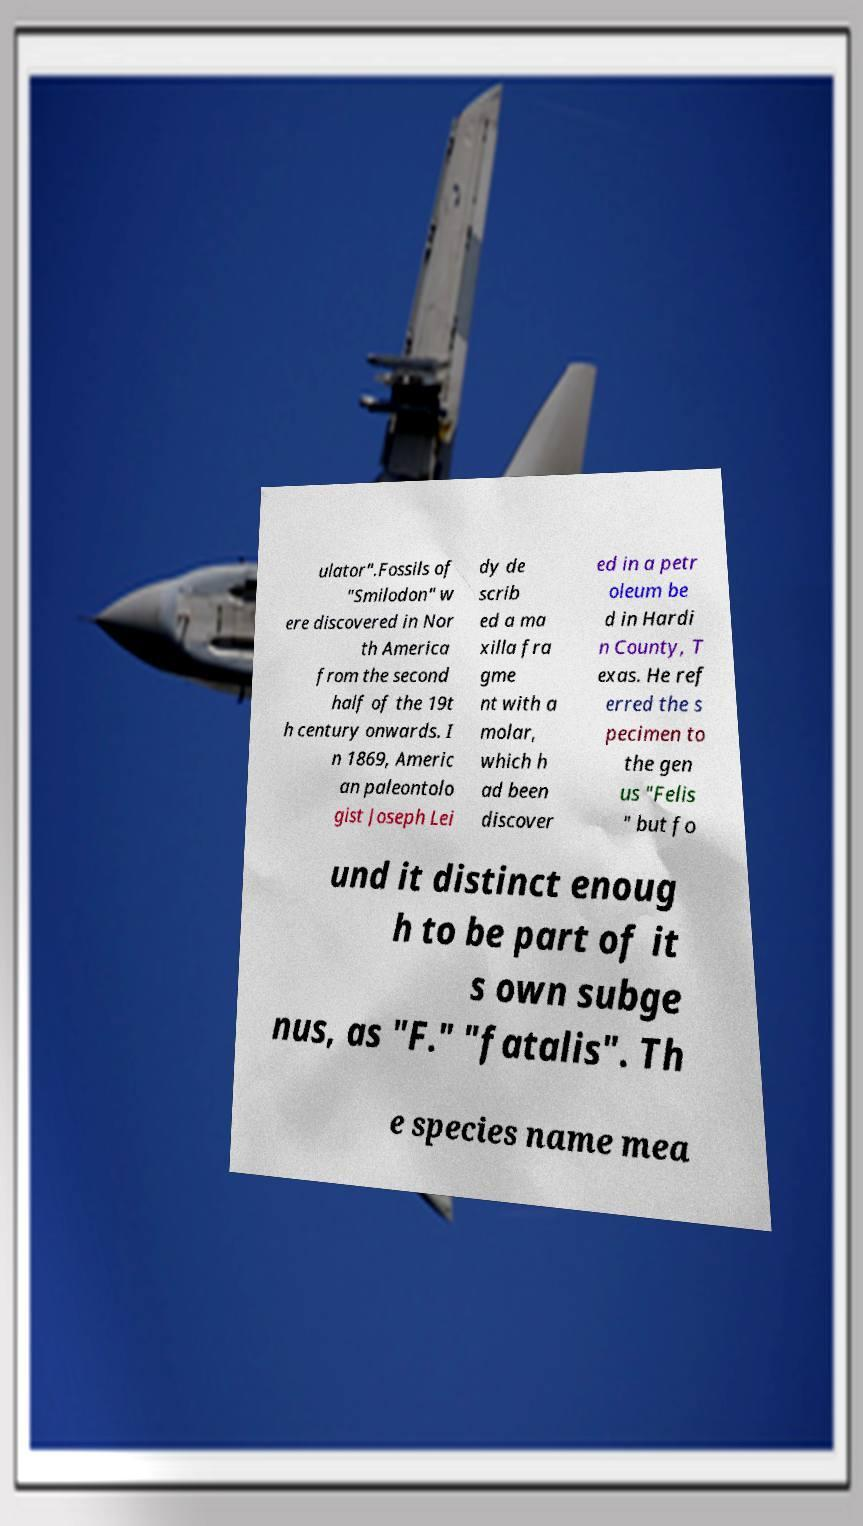There's text embedded in this image that I need extracted. Can you transcribe it verbatim? ulator".Fossils of "Smilodon" w ere discovered in Nor th America from the second half of the 19t h century onwards. I n 1869, Americ an paleontolo gist Joseph Lei dy de scrib ed a ma xilla fra gme nt with a molar, which h ad been discover ed in a petr oleum be d in Hardi n County, T exas. He ref erred the s pecimen to the gen us "Felis " but fo und it distinct enoug h to be part of it s own subge nus, as "F." "fatalis". Th e species name mea 